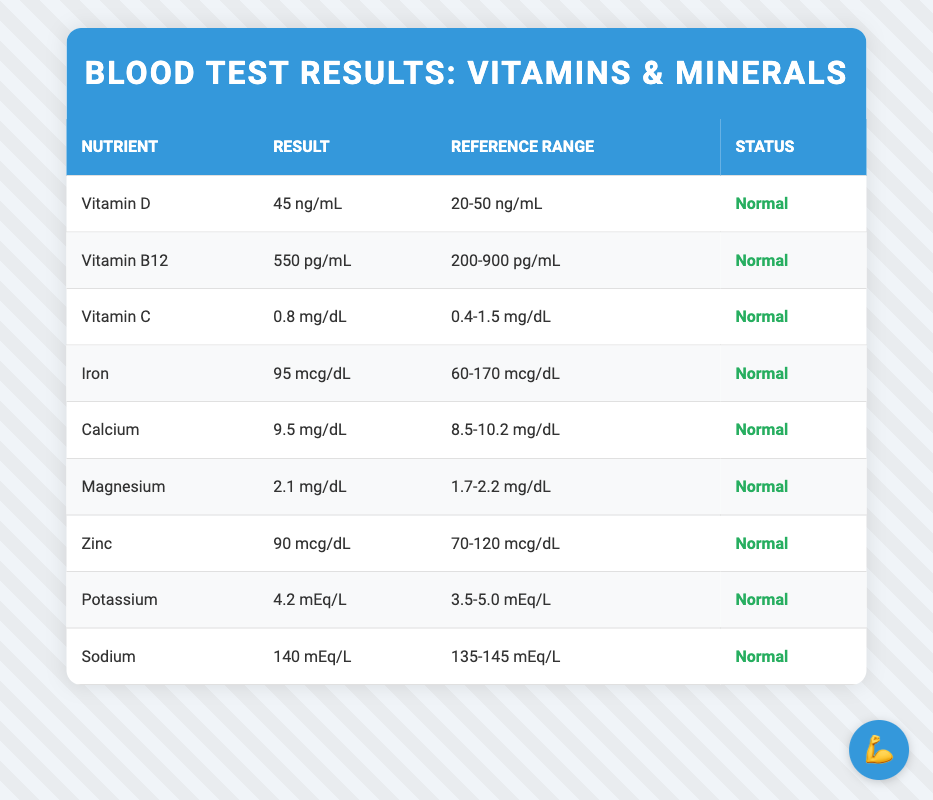What is the status of Vitamin D in the test results? The result for Vitamin D is 45 ng/mL, and the status indicated in the table is "Normal." Since 45 falls within the reference range of 20-50 ng/mL, this confirms that it is normal.
Answer: Normal Which vitamin has the highest result? The results for the vitamins are as follows: Vitamin D: 45 ng/mL, Vitamin B12: 550 pg/mL, and Vitamin C: 0.8 mg/dL. To compare, 45 ng/mL (Vitamin D) is greater than both 550 pg/mL (Vitamin B12) and 0.8 mg/dL (Vitamin C), implying that Vitamin D has the highest result.
Answer: Vitamin D Are any of the minerals below their normal reference range? The table states the normal ranges for each mineral: Iron (60-170 mcg/dL), Calcium (8.5-10.2 mg/dL), Magnesium (1.7-2.2 mg/dL), Zinc (70-120 mcg/dL), Potassium (3.5-5.0 mEq/L), and Sodium (135-145 mEq/L). All listed results are within their respective reference ranges, indicating that none are below normal.
Answer: No What is the average result of all the vitamins and minerals in the table? The results for vitamins and minerals are as follows: Vitamin D (45), Vitamin B12 (550), Vitamin C (0.8), Iron (95), Calcium (9.5), Magnesium (2.1), Zinc (90), Potassium (4.2), and Sodium (140). To find the average, we first sum them: 45 + 550 + 0.8 + 95 + 9.5 + 2.1 + 90 + 4.2 + 140 = 932.7. There are 9 data points, thus the average is 932.7 / 9 = approximately 103.63.
Answer: 103.63 Is the result for Sodium closer to its minimum or maximum reference range? Sodium has a result of 140 mEq/L, and the reference range is 135-145 mEq/L. The minimum value is 135, and the maximum is 145. The difference from the minimum is 140 - 135 = 5, and from the maximum is 145 - 140 = 5. Since both differences are equal, Sodium is equidistant from both the minimum and maximum values.
Answer: Equidistant How many nutrients are listed in the "Normal" status category? The table includes 9 nutrients: Vitamin D, Vitamin B12, Vitamin C, Iron, Calcium, Magnesium, Zinc, Potassium, and Sodium. Each has the status "Normal." Counting them gives a total of 9 nutrients all classified in the "Normal" status category.
Answer: 9 